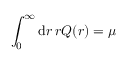<formula> <loc_0><loc_0><loc_500><loc_500>\int _ { 0 } ^ { \infty } d r \, r Q ( r ) = \mu</formula> 